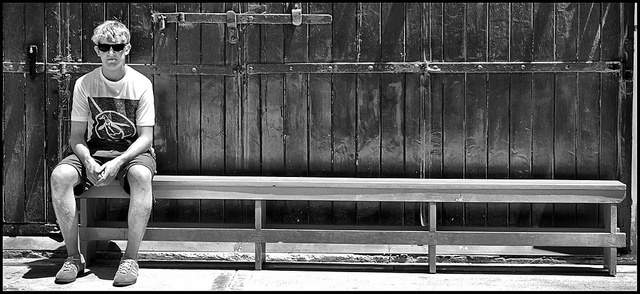Describe the objects in this image and their specific colors. I can see bench in black, gray, darkgray, and lightgray tones and people in black, darkgray, lightgray, and gray tones in this image. 